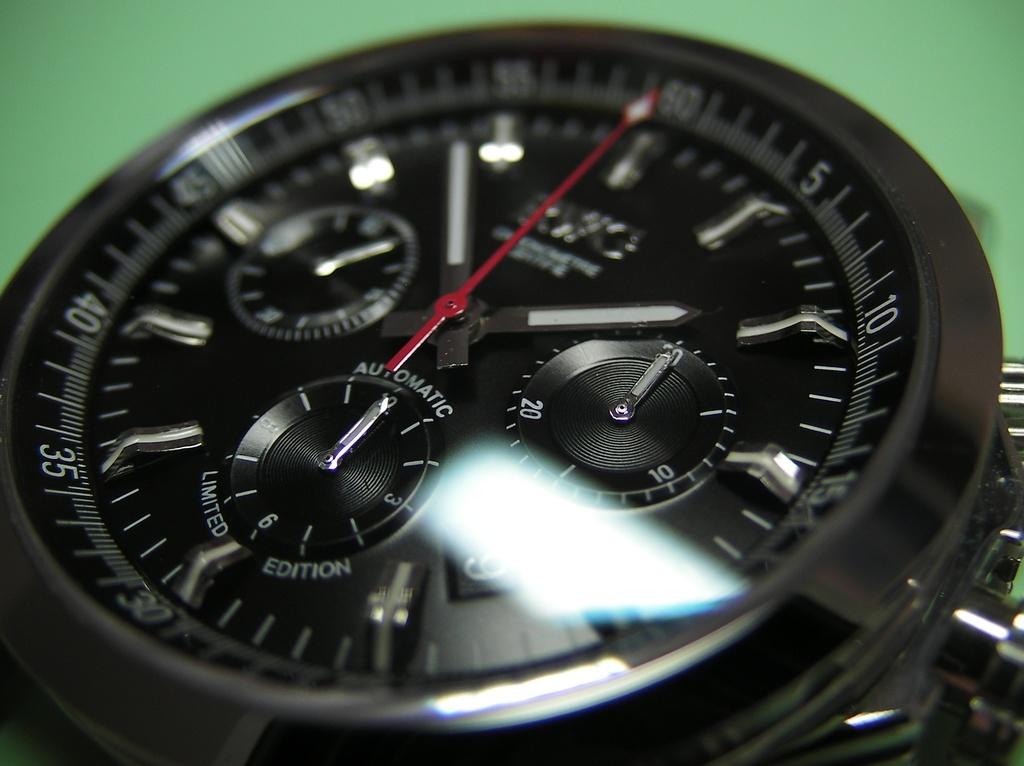What kind of edition is that watch?
Keep it short and to the point. Limited. What time is it?
Offer a terse response. 1:54. 